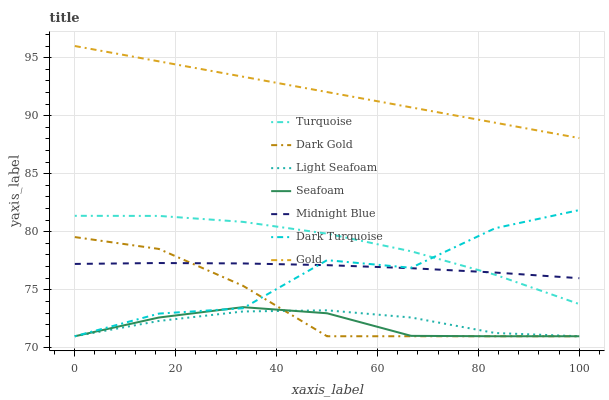Does Seafoam have the minimum area under the curve?
Answer yes or no. Yes. Does Gold have the maximum area under the curve?
Answer yes or no. Yes. Does Midnight Blue have the minimum area under the curve?
Answer yes or no. No. Does Midnight Blue have the maximum area under the curve?
Answer yes or no. No. Is Gold the smoothest?
Answer yes or no. Yes. Is Dark Turquoise the roughest?
Answer yes or no. Yes. Is Midnight Blue the smoothest?
Answer yes or no. No. Is Midnight Blue the roughest?
Answer yes or no. No. Does Dark Gold have the lowest value?
Answer yes or no. Yes. Does Midnight Blue have the lowest value?
Answer yes or no. No. Does Gold have the highest value?
Answer yes or no. Yes. Does Midnight Blue have the highest value?
Answer yes or no. No. Is Light Seafoam less than Gold?
Answer yes or no. Yes. Is Midnight Blue greater than Seafoam?
Answer yes or no. Yes. Does Dark Gold intersect Light Seafoam?
Answer yes or no. Yes. Is Dark Gold less than Light Seafoam?
Answer yes or no. No. Is Dark Gold greater than Light Seafoam?
Answer yes or no. No. Does Light Seafoam intersect Gold?
Answer yes or no. No. 